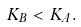Convert formula to latex. <formula><loc_0><loc_0><loc_500><loc_500>K _ { B } < K _ { A } .</formula> 